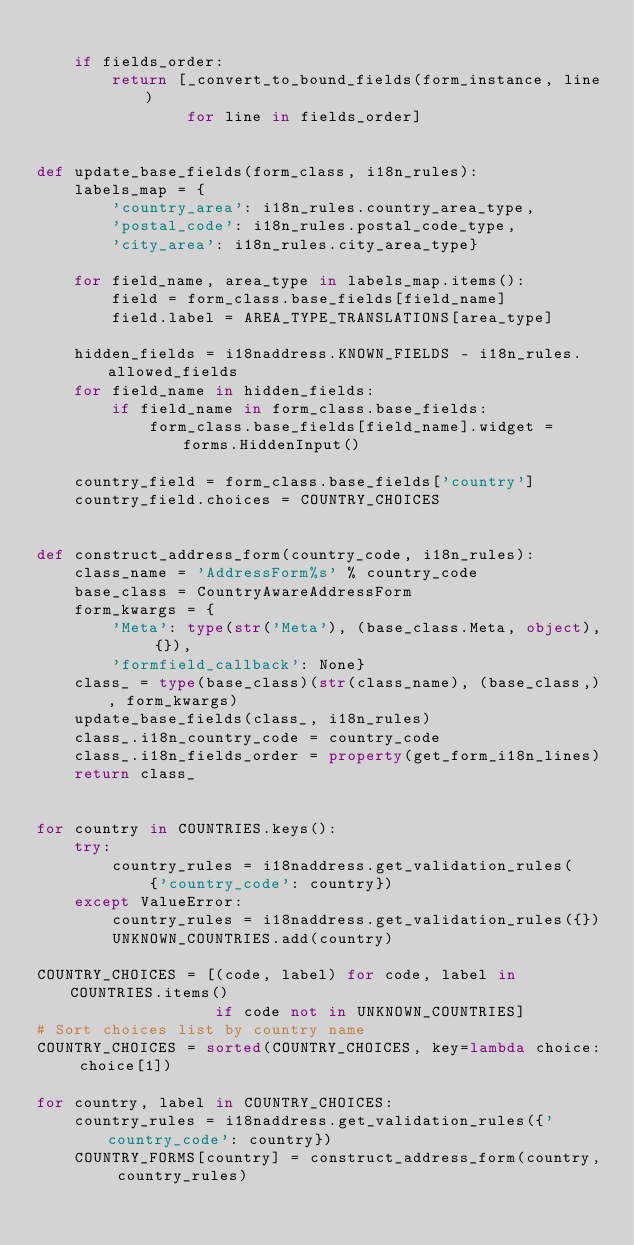<code> <loc_0><loc_0><loc_500><loc_500><_Python_>
    if fields_order:
        return [_convert_to_bound_fields(form_instance, line)
                for line in fields_order]


def update_base_fields(form_class, i18n_rules):
    labels_map = {
        'country_area': i18n_rules.country_area_type,
        'postal_code': i18n_rules.postal_code_type,
        'city_area': i18n_rules.city_area_type}

    for field_name, area_type in labels_map.items():
        field = form_class.base_fields[field_name]
        field.label = AREA_TYPE_TRANSLATIONS[area_type]

    hidden_fields = i18naddress.KNOWN_FIELDS - i18n_rules.allowed_fields
    for field_name in hidden_fields:
        if field_name in form_class.base_fields:
            form_class.base_fields[field_name].widget = forms.HiddenInput()

    country_field = form_class.base_fields['country']
    country_field.choices = COUNTRY_CHOICES


def construct_address_form(country_code, i18n_rules):
    class_name = 'AddressForm%s' % country_code
    base_class = CountryAwareAddressForm
    form_kwargs = {
        'Meta': type(str('Meta'), (base_class.Meta, object), {}),
        'formfield_callback': None}
    class_ = type(base_class)(str(class_name), (base_class,), form_kwargs)
    update_base_fields(class_, i18n_rules)
    class_.i18n_country_code = country_code
    class_.i18n_fields_order = property(get_form_i18n_lines)
    return class_


for country in COUNTRIES.keys():
    try:
        country_rules = i18naddress.get_validation_rules(
            {'country_code': country})
    except ValueError:
        country_rules = i18naddress.get_validation_rules({})
        UNKNOWN_COUNTRIES.add(country)

COUNTRY_CHOICES = [(code, label) for code, label in COUNTRIES.items()
                   if code not in UNKNOWN_COUNTRIES]
# Sort choices list by country name
COUNTRY_CHOICES = sorted(COUNTRY_CHOICES, key=lambda choice: choice[1])

for country, label in COUNTRY_CHOICES:
    country_rules = i18naddress.get_validation_rules({'country_code': country})
    COUNTRY_FORMS[country] = construct_address_form(country, country_rules)
</code> 